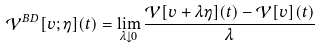Convert formula to latex. <formula><loc_0><loc_0><loc_500><loc_500>\mathcal { V } ^ { B D } [ v ; \eta ] ( t ) = \lim _ { \lambda \downarrow 0 } \frac { \mathcal { V } [ v + \lambda \eta ] ( t ) - \mathcal { V } [ v ] ( t ) } { \lambda }</formula> 